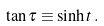<formula> <loc_0><loc_0><loc_500><loc_500>\tan \tau \equiv \sinh t \, .</formula> 